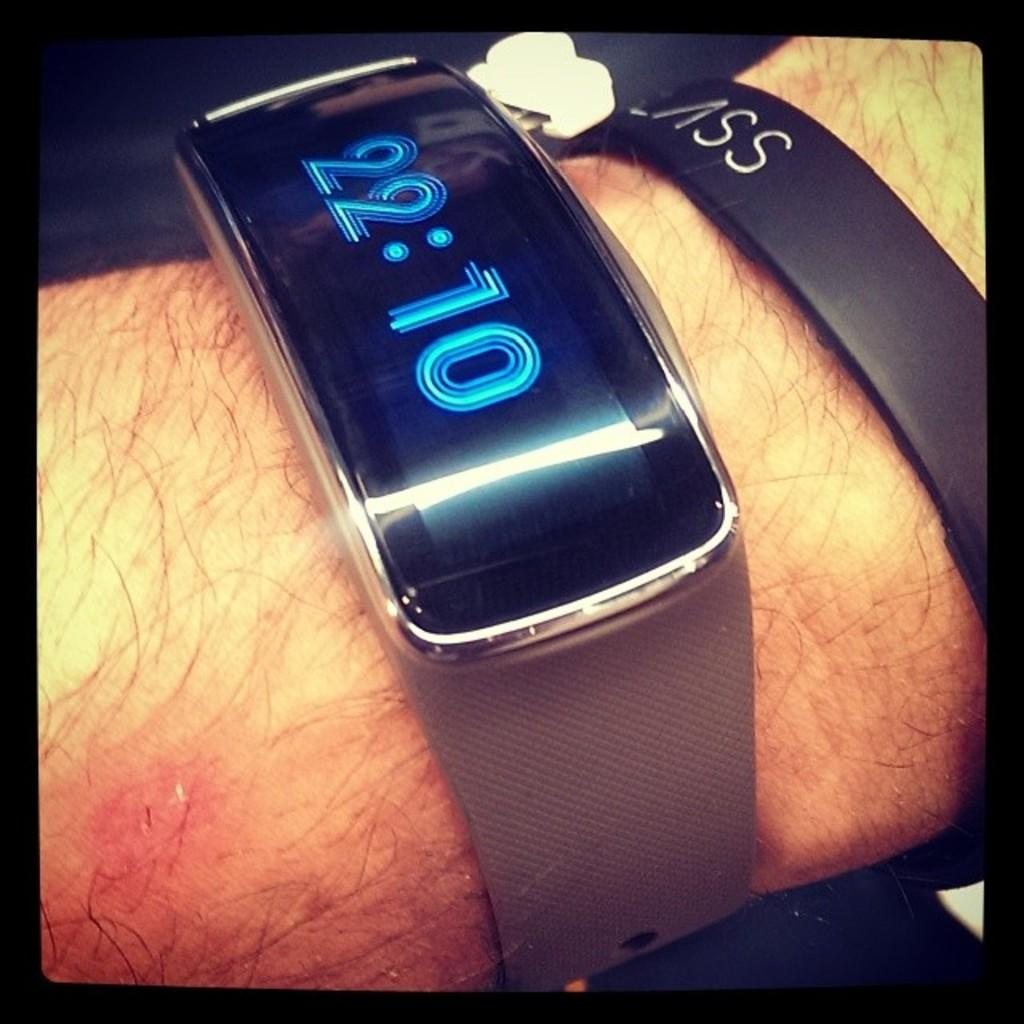What can be seen in the image that belongs to a person? There is a person's hand in the image. What is the person's hand holding? The person's hand is holding a digital watch. What additional feature can be observed on the digital watch? There is a band on the digital watch. How are the edges of the image defined? The image has black color borders. How many flies can be seen on the digital watch in the image? There are no flies present in the image. What level of experience does the secretary have in the image? There is no secretary present in the image. 